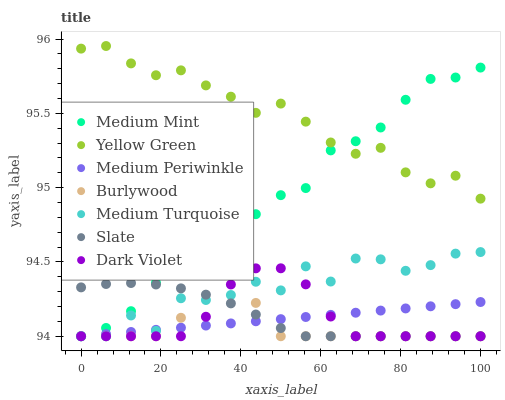Does Burlywood have the minimum area under the curve?
Answer yes or no. Yes. Does Yellow Green have the maximum area under the curve?
Answer yes or no. Yes. Does Yellow Green have the minimum area under the curve?
Answer yes or no. No. Does Burlywood have the maximum area under the curve?
Answer yes or no. No. Is Medium Periwinkle the smoothest?
Answer yes or no. Yes. Is Medium Turquoise the roughest?
Answer yes or no. Yes. Is Yellow Green the smoothest?
Answer yes or no. No. Is Yellow Green the roughest?
Answer yes or no. No. Does Medium Mint have the lowest value?
Answer yes or no. Yes. Does Yellow Green have the lowest value?
Answer yes or no. No. Does Yellow Green have the highest value?
Answer yes or no. Yes. Does Burlywood have the highest value?
Answer yes or no. No. Is Slate less than Yellow Green?
Answer yes or no. Yes. Is Yellow Green greater than Medium Periwinkle?
Answer yes or no. Yes. Does Medium Periwinkle intersect Medium Turquoise?
Answer yes or no. Yes. Is Medium Periwinkle less than Medium Turquoise?
Answer yes or no. No. Is Medium Periwinkle greater than Medium Turquoise?
Answer yes or no. No. Does Slate intersect Yellow Green?
Answer yes or no. No. 